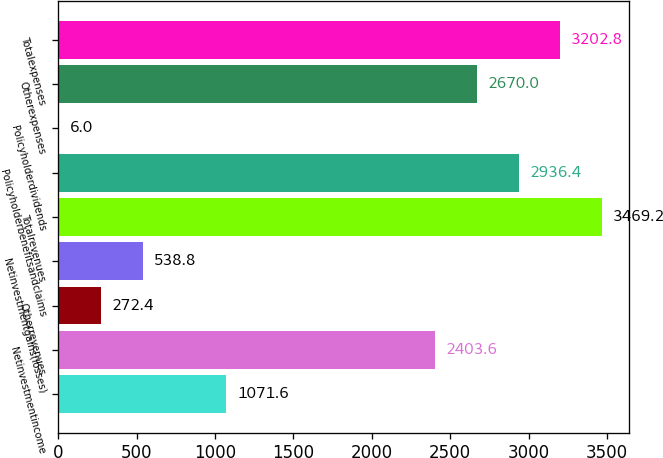Convert chart to OTSL. <chart><loc_0><loc_0><loc_500><loc_500><bar_chart><ecel><fcel>Netinvestmentincome<fcel>Otherrevenues<fcel>Netinvestmentgains(losses)<fcel>Totalrevenues<fcel>Policyholderbenefitsandclaims<fcel>Policyholderdividends<fcel>Otherexpenses<fcel>Totalexpenses<nl><fcel>1071.6<fcel>2403.6<fcel>272.4<fcel>538.8<fcel>3469.2<fcel>2936.4<fcel>6<fcel>2670<fcel>3202.8<nl></chart> 